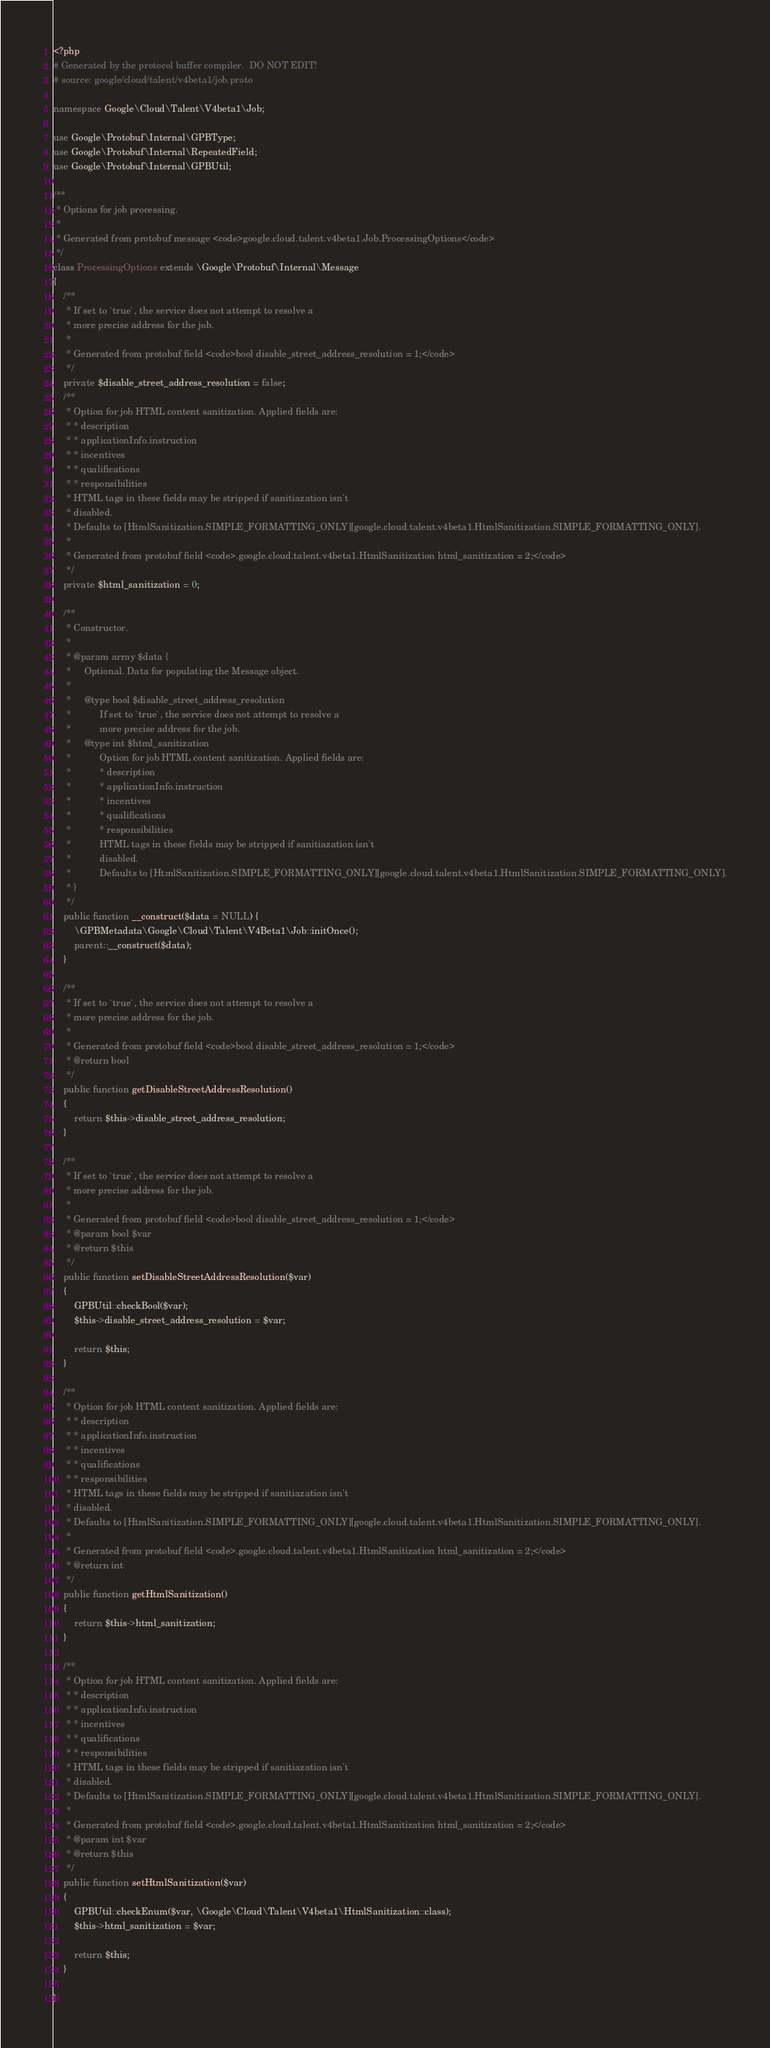<code> <loc_0><loc_0><loc_500><loc_500><_PHP_><?php
# Generated by the protocol buffer compiler.  DO NOT EDIT!
# source: google/cloud/talent/v4beta1/job.proto

namespace Google\Cloud\Talent\V4beta1\Job;

use Google\Protobuf\Internal\GPBType;
use Google\Protobuf\Internal\RepeatedField;
use Google\Protobuf\Internal\GPBUtil;

/**
 * Options for job processing.
 *
 * Generated from protobuf message <code>google.cloud.talent.v4beta1.Job.ProcessingOptions</code>
 */
class ProcessingOptions extends \Google\Protobuf\Internal\Message
{
    /**
     * If set to `true`, the service does not attempt to resolve a
     * more precise address for the job.
     *
     * Generated from protobuf field <code>bool disable_street_address_resolution = 1;</code>
     */
    private $disable_street_address_resolution = false;
    /**
     * Option for job HTML content sanitization. Applied fields are:
     * * description
     * * applicationInfo.instruction
     * * incentives
     * * qualifications
     * * responsibilities
     * HTML tags in these fields may be stripped if sanitiazation isn't
     * disabled.
     * Defaults to [HtmlSanitization.SIMPLE_FORMATTING_ONLY][google.cloud.talent.v4beta1.HtmlSanitization.SIMPLE_FORMATTING_ONLY].
     *
     * Generated from protobuf field <code>.google.cloud.talent.v4beta1.HtmlSanitization html_sanitization = 2;</code>
     */
    private $html_sanitization = 0;

    /**
     * Constructor.
     *
     * @param array $data {
     *     Optional. Data for populating the Message object.
     *
     *     @type bool $disable_street_address_resolution
     *           If set to `true`, the service does not attempt to resolve a
     *           more precise address for the job.
     *     @type int $html_sanitization
     *           Option for job HTML content sanitization. Applied fields are:
     *           * description
     *           * applicationInfo.instruction
     *           * incentives
     *           * qualifications
     *           * responsibilities
     *           HTML tags in these fields may be stripped if sanitiazation isn't
     *           disabled.
     *           Defaults to [HtmlSanitization.SIMPLE_FORMATTING_ONLY][google.cloud.talent.v4beta1.HtmlSanitization.SIMPLE_FORMATTING_ONLY].
     * }
     */
    public function __construct($data = NULL) {
        \GPBMetadata\Google\Cloud\Talent\V4Beta1\Job::initOnce();
        parent::__construct($data);
    }

    /**
     * If set to `true`, the service does not attempt to resolve a
     * more precise address for the job.
     *
     * Generated from protobuf field <code>bool disable_street_address_resolution = 1;</code>
     * @return bool
     */
    public function getDisableStreetAddressResolution()
    {
        return $this->disable_street_address_resolution;
    }

    /**
     * If set to `true`, the service does not attempt to resolve a
     * more precise address for the job.
     *
     * Generated from protobuf field <code>bool disable_street_address_resolution = 1;</code>
     * @param bool $var
     * @return $this
     */
    public function setDisableStreetAddressResolution($var)
    {
        GPBUtil::checkBool($var);
        $this->disable_street_address_resolution = $var;

        return $this;
    }

    /**
     * Option for job HTML content sanitization. Applied fields are:
     * * description
     * * applicationInfo.instruction
     * * incentives
     * * qualifications
     * * responsibilities
     * HTML tags in these fields may be stripped if sanitiazation isn't
     * disabled.
     * Defaults to [HtmlSanitization.SIMPLE_FORMATTING_ONLY][google.cloud.talent.v4beta1.HtmlSanitization.SIMPLE_FORMATTING_ONLY].
     *
     * Generated from protobuf field <code>.google.cloud.talent.v4beta1.HtmlSanitization html_sanitization = 2;</code>
     * @return int
     */
    public function getHtmlSanitization()
    {
        return $this->html_sanitization;
    }

    /**
     * Option for job HTML content sanitization. Applied fields are:
     * * description
     * * applicationInfo.instruction
     * * incentives
     * * qualifications
     * * responsibilities
     * HTML tags in these fields may be stripped if sanitiazation isn't
     * disabled.
     * Defaults to [HtmlSanitization.SIMPLE_FORMATTING_ONLY][google.cloud.talent.v4beta1.HtmlSanitization.SIMPLE_FORMATTING_ONLY].
     *
     * Generated from protobuf field <code>.google.cloud.talent.v4beta1.HtmlSanitization html_sanitization = 2;</code>
     * @param int $var
     * @return $this
     */
    public function setHtmlSanitization($var)
    {
        GPBUtil::checkEnum($var, \Google\Cloud\Talent\V4beta1\HtmlSanitization::class);
        $this->html_sanitization = $var;

        return $this;
    }

}


</code> 